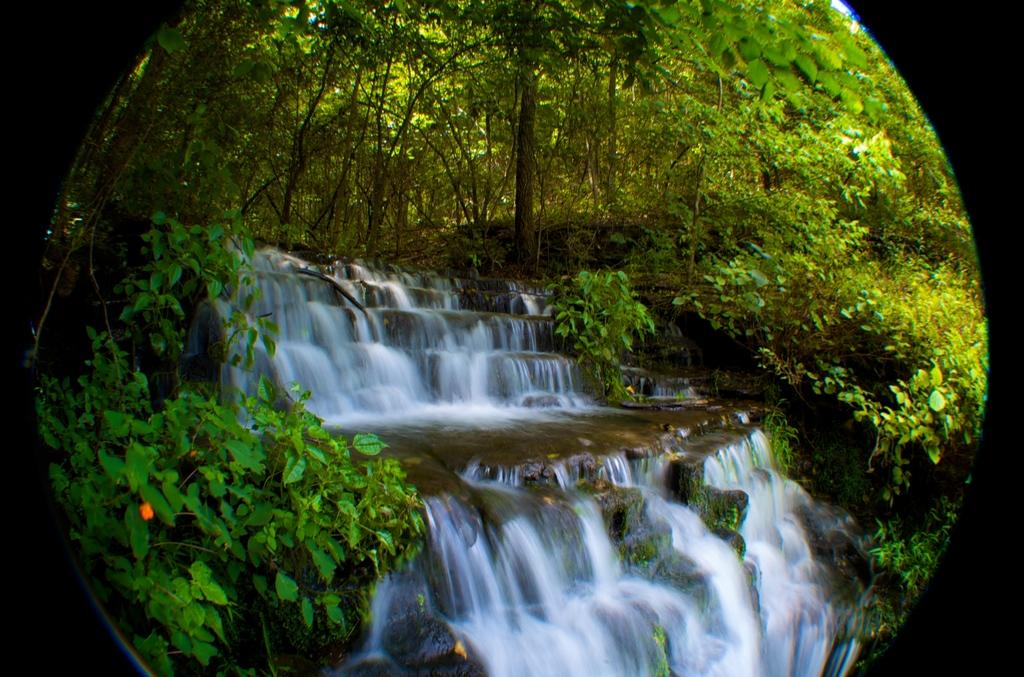What feature surrounds the main content of the image? The image has borders. What can be seen in the center of the image? There is running water in the center of the image. What type of vegetation is present in the image? There are plants and trees in the image. What type of natural formation can be seen in the image? There are rocks in the image. What other objects are present in the image? There are other objects in the image, but their specific nature is not mentioned in the provided facts. What type of crayon is being used to draw the acoustics of the band in the image? There is no crayon, acoustics, or band present in the image. 